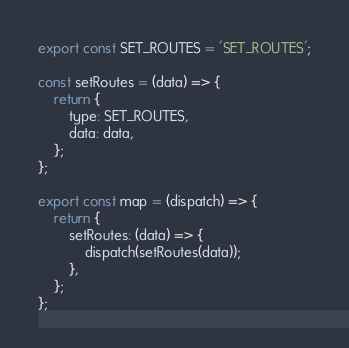<code> <loc_0><loc_0><loc_500><loc_500><_JavaScript_>export const SET_ROUTES = 'SET_ROUTES';

const setRoutes = (data) => {
    return {
        type: SET_ROUTES,
        data: data,
    };
};

export const map = (dispatch) => {
    return {
        setRoutes: (data) => {
            dispatch(setRoutes(data));
        },
    };
};
</code> 